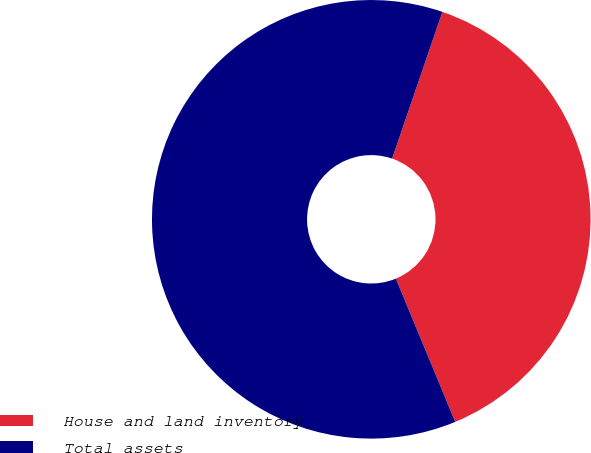Convert chart. <chart><loc_0><loc_0><loc_500><loc_500><pie_chart><fcel>House and land inventory<fcel>Total assets<nl><fcel>38.49%<fcel>61.51%<nl></chart> 